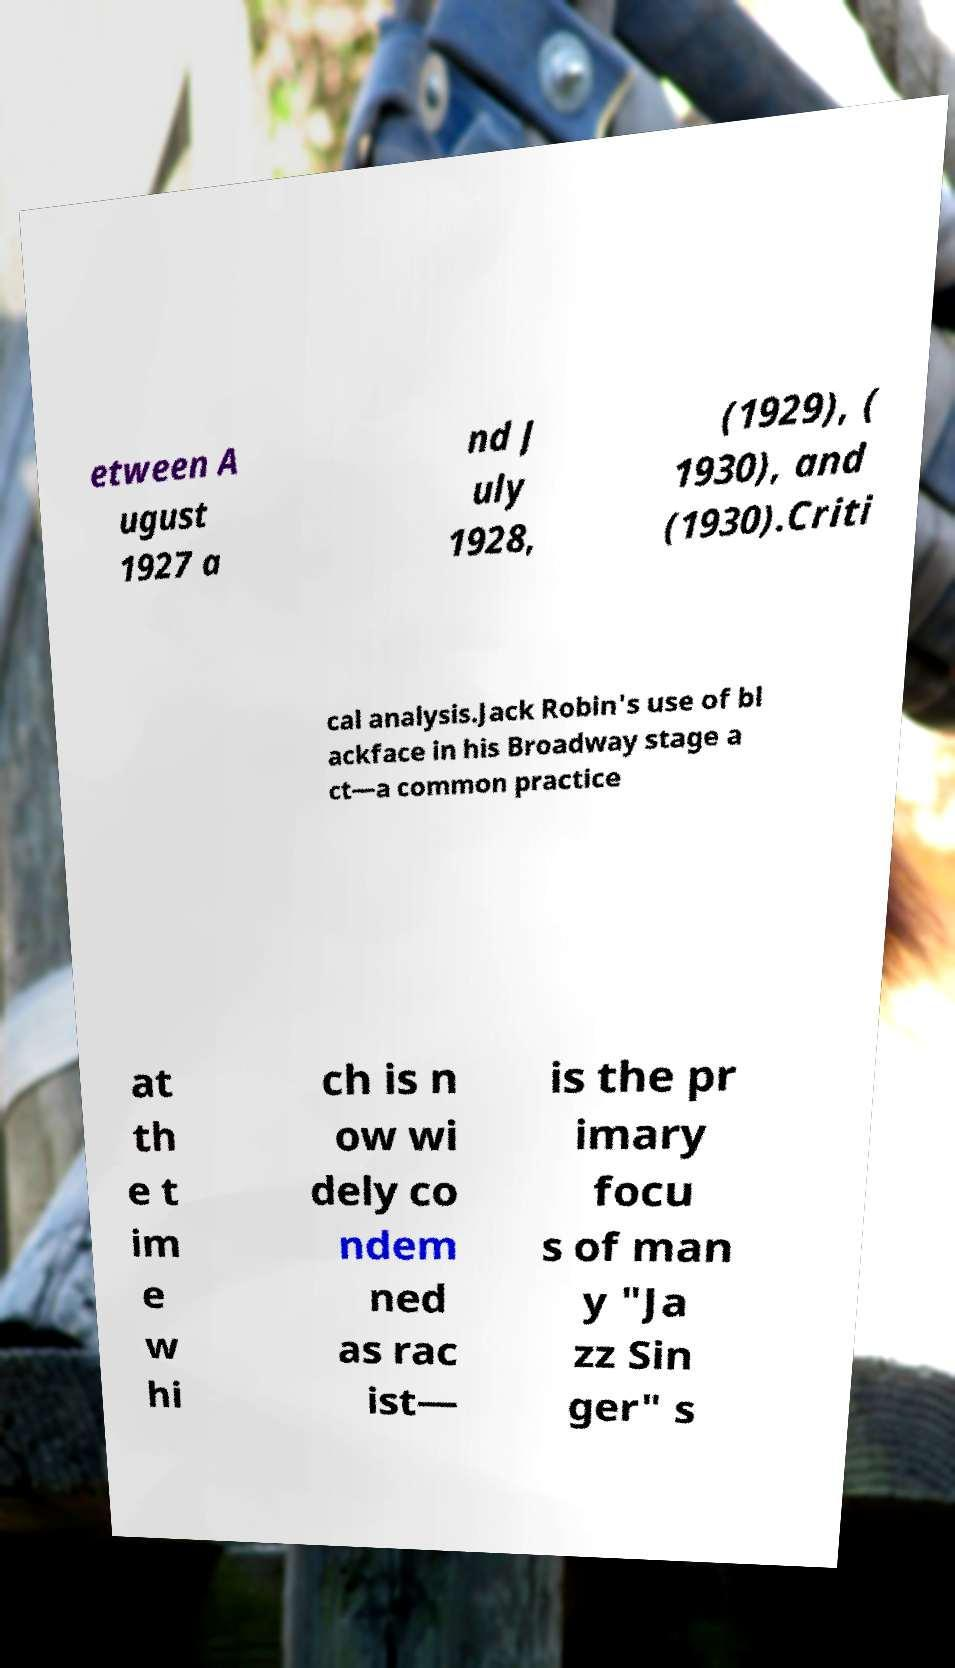Could you extract and type out the text from this image? etween A ugust 1927 a nd J uly 1928, (1929), ( 1930), and (1930).Criti cal analysis.Jack Robin's use of bl ackface in his Broadway stage a ct—a common practice at th e t im e w hi ch is n ow wi dely co ndem ned as rac ist— is the pr imary focu s of man y "Ja zz Sin ger" s 